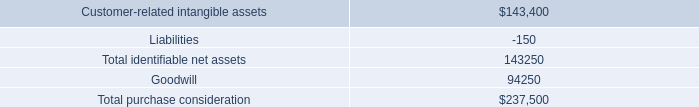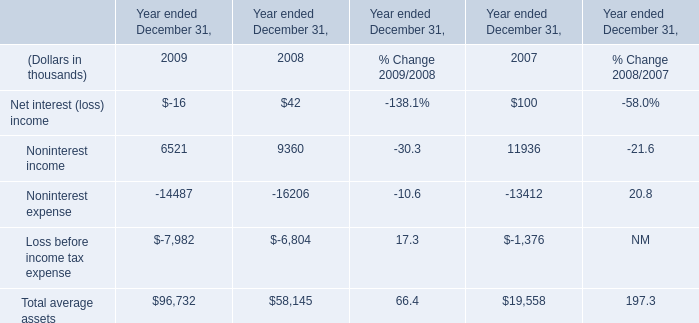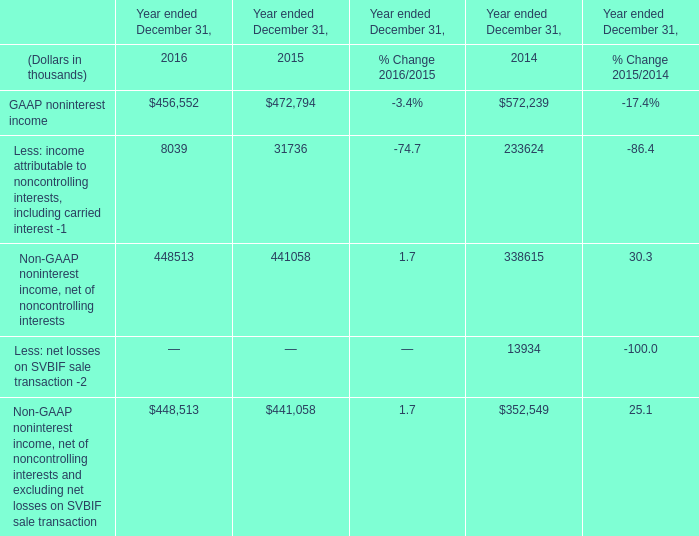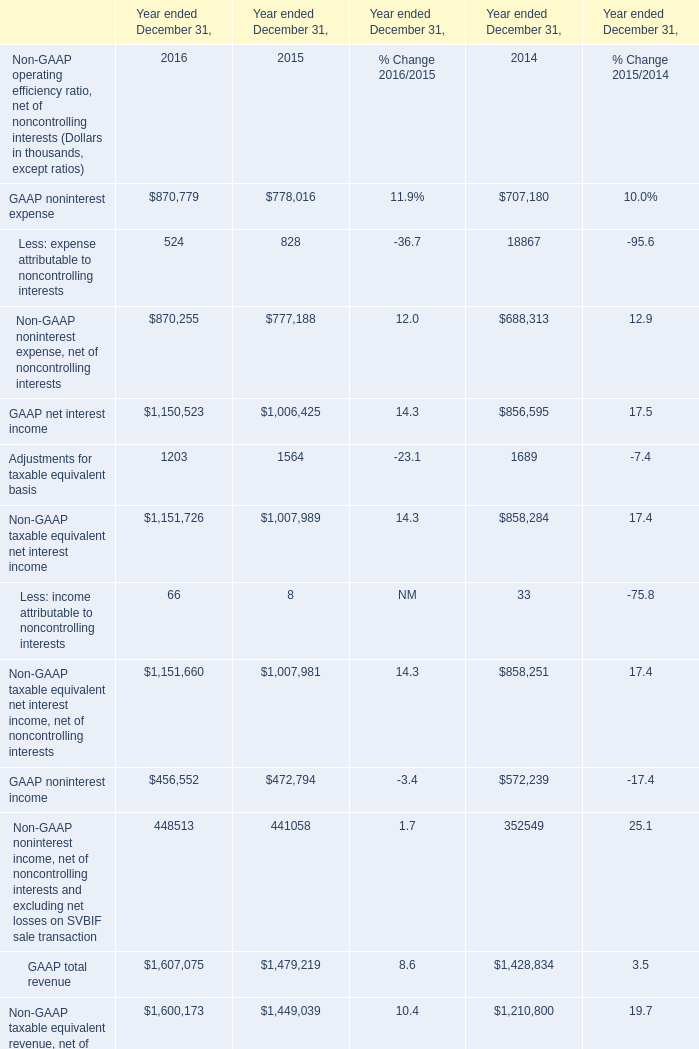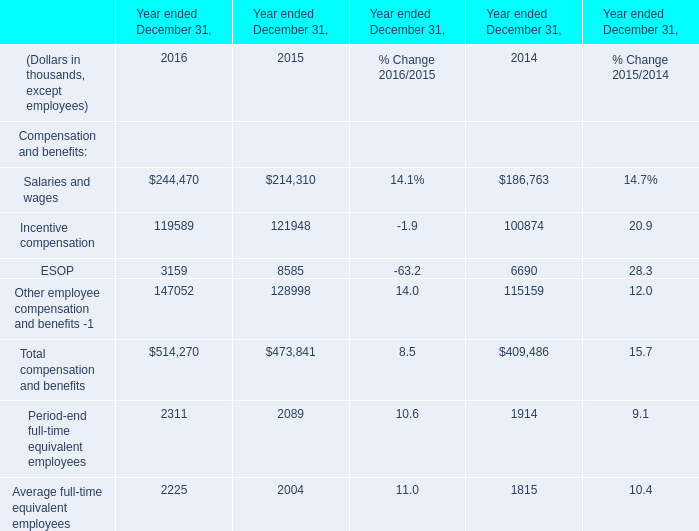If Salaries and wages develops with the same increasing rate in 2016, what will it reach in 2017? (in thousand) 
Computations: (244470 * (1 + ((244470 - 214310) / 214310)))
Answer: 278874.43843. 